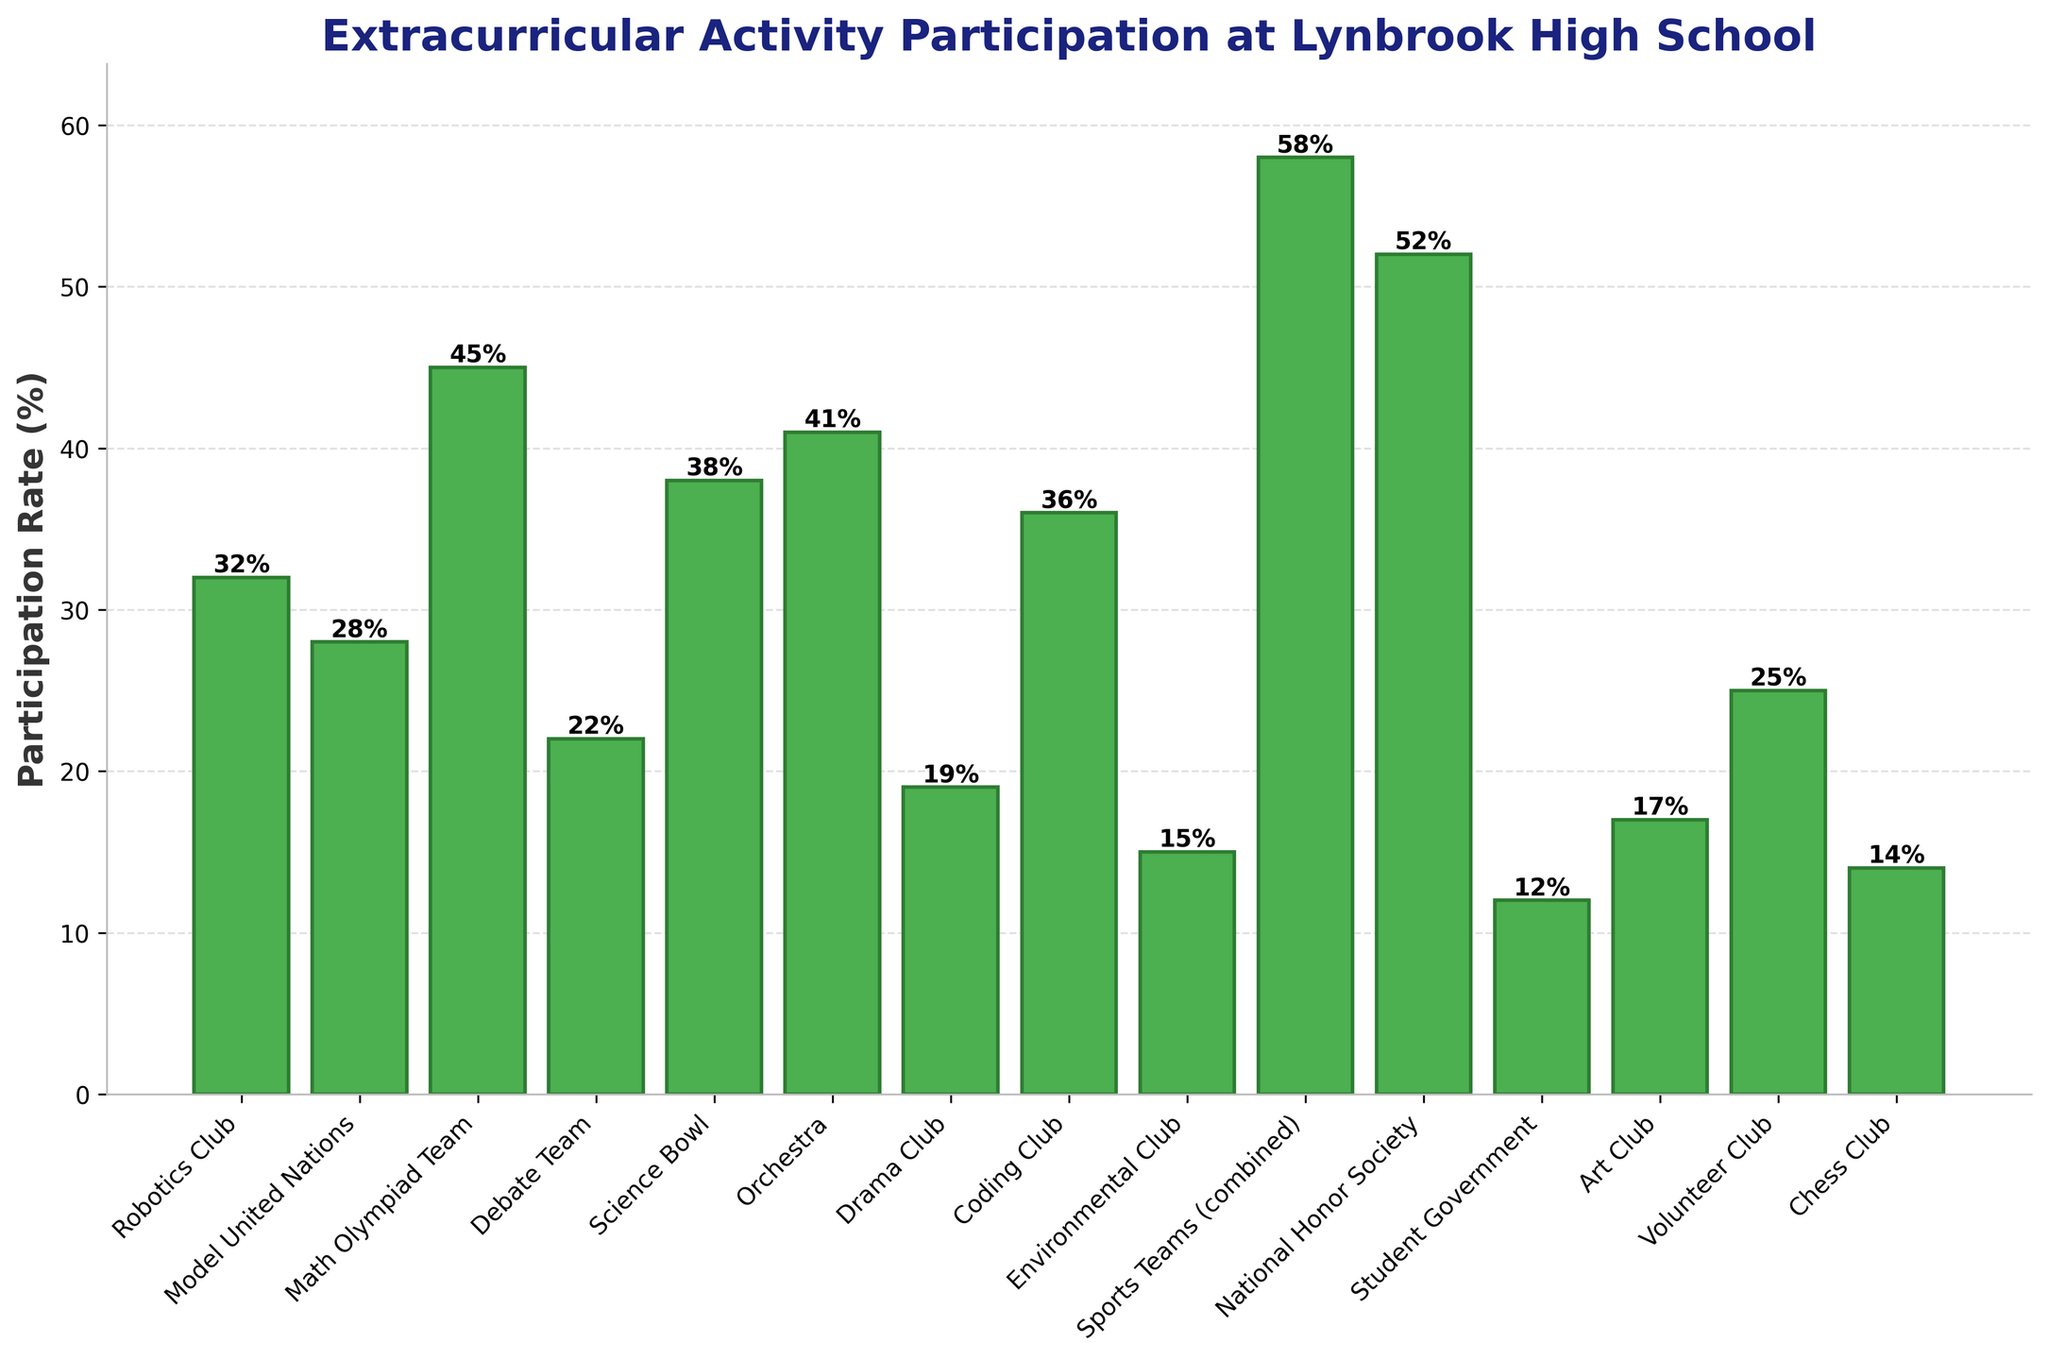What is the participation rate of the National Honor Society? Locate the bar labeled "National Honor Society" and observe its height. The label on the bar indicates the participation rate.
Answer: 52% Which activity has the highest participation rate? Examine all the bars to identify the tallest one. The tallest bar represents the activity with the highest participation rate.
Answer: Sports Teams How much more is the participation rate of the Math Olympiad Team compared to the Debate Team? Find the heights of the bars labeled "Math Olympiad Team" (45%) and "Debate Team" (22%). Subtract the Debate Team's rate from the Math Olympiad Team's rate: 45% - 22% = 23%.
Answer: 23% What is the average participation rate of the Robotics Club, Model United Nations, and Coding Club? Locate the heights of the bars labeled "Robotics Club" (32%), "Model United Nations" (28%), and "Coding Club" (36%). Add these participation rates: 32% + 28% + 36% = 96%. Divide by the number of activities: 96% / 3 = 32%.
Answer: 32% Is the participation rate of the Student Government greater than or less than the Environmental Club? Compare the heights of the bars labeled "Student Government" (12%) and "Environmental Club" (15%). The Student Government's rate is lower.
Answer: Less than What is the participation rate difference between the Chess Club and the Drama Club? Find the heights of the bars for "Chess Club" (14%) and "Drama Club" (19%). Calculate the difference: 19% - 14% = 5%.
Answer: 5% Which activities have participation rates below 20%? Identify the bars with heights less than 20%. These are "Drama Club" (19%), "Environmental Club" (15%), "Student Government" (12%), "Art Club" (17%), and "Chess Club" (14%).
Answer: Drama Club, Environmental Club, Student Government, Art Club, Chess Club How many activities have participation rates higher than 40%? Count the bars with heights above 40%. These are "Math Olympiad Team" (45%), "Science Bowl" (38%), "Orchestra" (41%), "Sports Teams (combined)" (58%), and "National Honor Society" (52%).
Answer: 5 